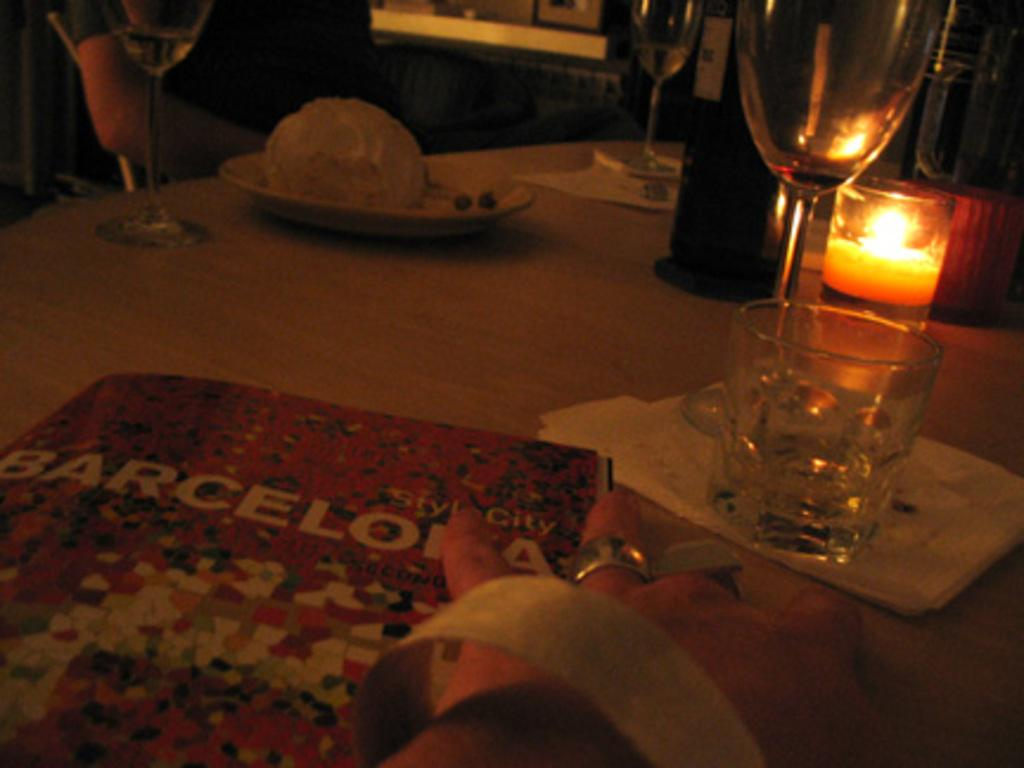What is the main object on the table in the image? There is a food item on the table. What other items can be seen on the table? There is a candle, bottles, glasses, and a book on the table. Can you describe the hand of a person in the image? A hand of a person is beside the book on the table. How many jellyfish are swimming in the book on the table? There are no jellyfish present in the image, and the book does not contain any water for them to swim in. 